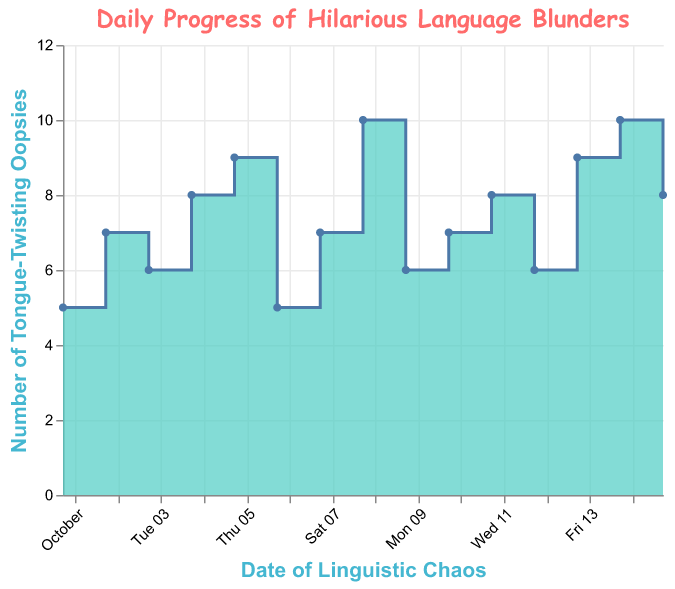How many hilarious language blunders occurred on 2023-10-04? Look at the data point for 2023-10-04. The corresponding number of funny mistakes is 8.
Answer: 8 What's the maximum number of tongue-twisting mistakes recorded throughout the period? Find the highest value on the y-axis which represents funny mistakes. The maximum value is 10.
Answer: 10 Which date saw a drop in the number of humorous mistakes compared to the previous day? Compare the number of funny mistakes from one day to the next. The transition from 2023-10-05 to 2023-10-06 shows a decrease from 9 to 5.
Answer: 2023-10-06 What is the average number of mistakes per day over the first seven days? Sum the number of mistakes from 2023-10-01 to 2023-10-07 (5 + 7 + 6 + 8 + 9 + 5 + 7) and then divide by the number of days (7). 47 / 7 ≈ 6.71.
Answer: 6.71 How many days had exactly 7 language blunders? Count the data points where the value of funny mistakes is 7. These occur on 2023-10-02, 2023-10-07, and 2023-10-10, totaling 3 days.
Answer: 3 On which date was there the largest single-day increase in funny mistakes? Compare day-to-day changes in values and find the maximum increase. The change from 2023-10-07 to 2023-10-08 is the largest, increasing by 3 mistakes (7 to 10).
Answer: 2023-10-08 What is the total number of funny mistakes recorded in the entire period? Sum all the values of funny mistakes over the period (5 + 7 + 6 + 8 + 9 + 5 + 7 + 10 + 6 + 7 + 8 + 6 + 9 + 10 + 8) which equals 111.
Answer: 111 Which date had the smallest number of tongue-twisting accidents? Identify the smallest value on the y-axis, which represents funny mistakes. This occurs on 2023-10-01 and 2023-10-06 with 5 mistakes each.
Answer: 2023-10-01 and 2023-10-06 